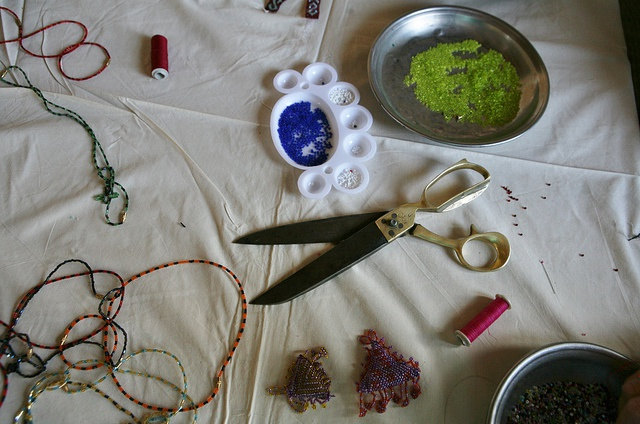Describe the objects in this image and their specific colors. I can see scissors in darkgray, black, olive, and gray tones and bowl in darkgray, black, purple, and lightgray tones in this image. 